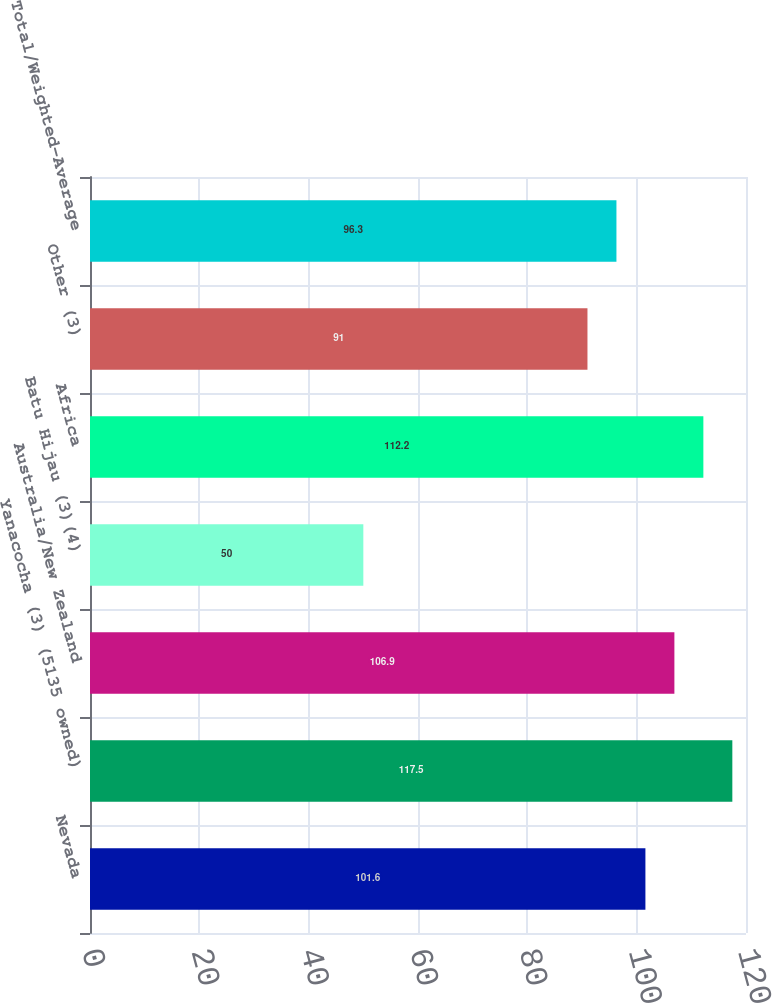Convert chart to OTSL. <chart><loc_0><loc_0><loc_500><loc_500><bar_chart><fcel>Nevada<fcel>Yanacocha (3) (5135 owned)<fcel>Australia/New Zealand<fcel>Batu Hijau (3)(4)<fcel>Africa<fcel>Other (3)<fcel>Total/Weighted-Average<nl><fcel>101.6<fcel>117.5<fcel>106.9<fcel>50<fcel>112.2<fcel>91<fcel>96.3<nl></chart> 